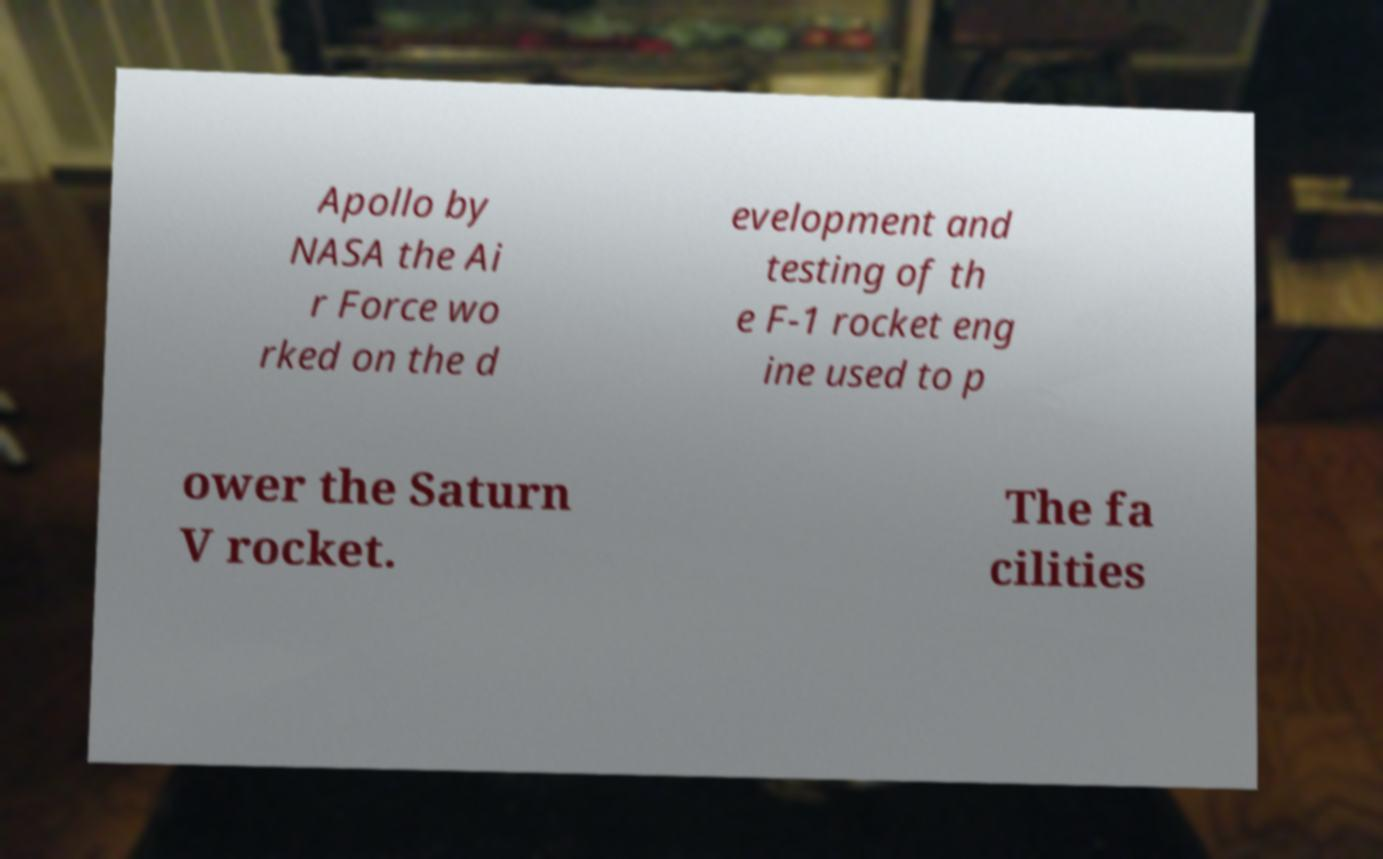What messages or text are displayed in this image? I need them in a readable, typed format. Apollo by NASA the Ai r Force wo rked on the d evelopment and testing of th e F-1 rocket eng ine used to p ower the Saturn V rocket. The fa cilities 